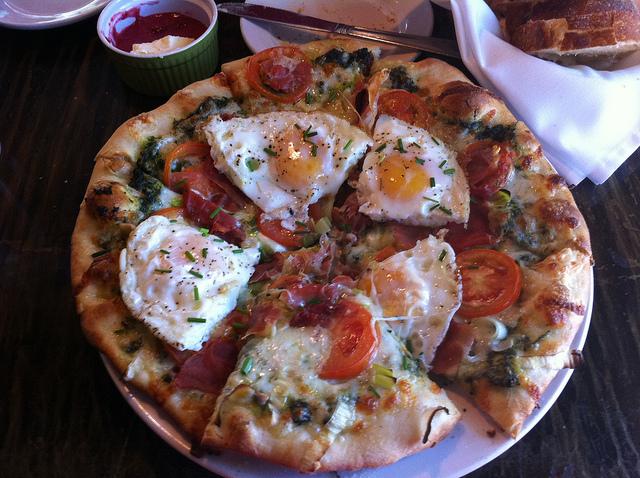What topping is on the pizza?
Concise answer only. Eggs. Is there any bread on the table?
Concise answer only. Yes. How many slices is this cut into?
Keep it brief. 6. 